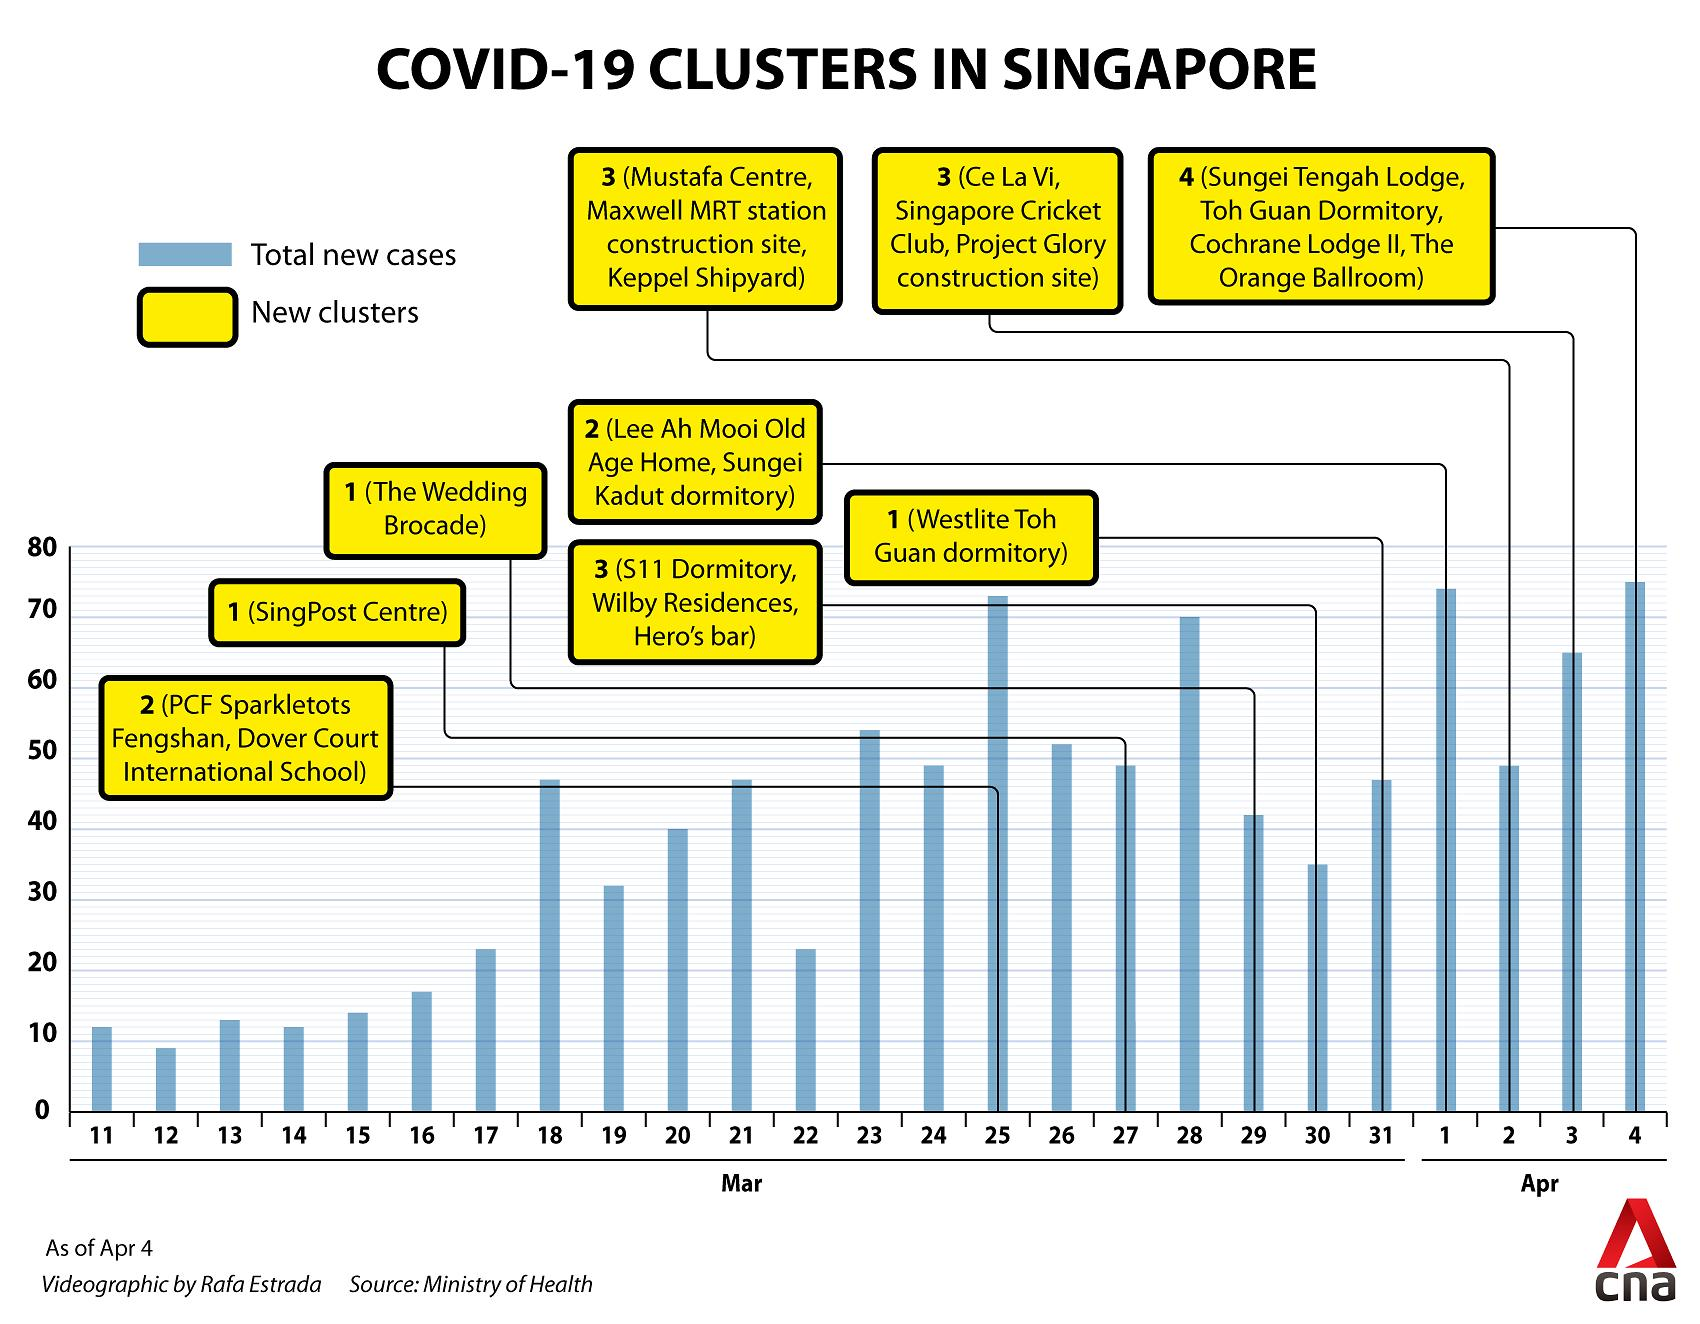List a handful of essential elements in this visual. On which date in March was The Wedding Brocade declared as a COVID-19 cluster? This event occurred on March 29th. On April 1st, COVID-19 clusters were marked in the areas of Lee Ah Mooi Old Age Home and Sungei Kadut dormitory in Singapore. On March 22, how many new cases were declared? On April 4th, four new COVID-19 clusters were declared in Singapore. On which date in April were 65 new cases declared? 